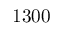<formula> <loc_0><loc_0><loc_500><loc_500>1 3 0 0</formula> 